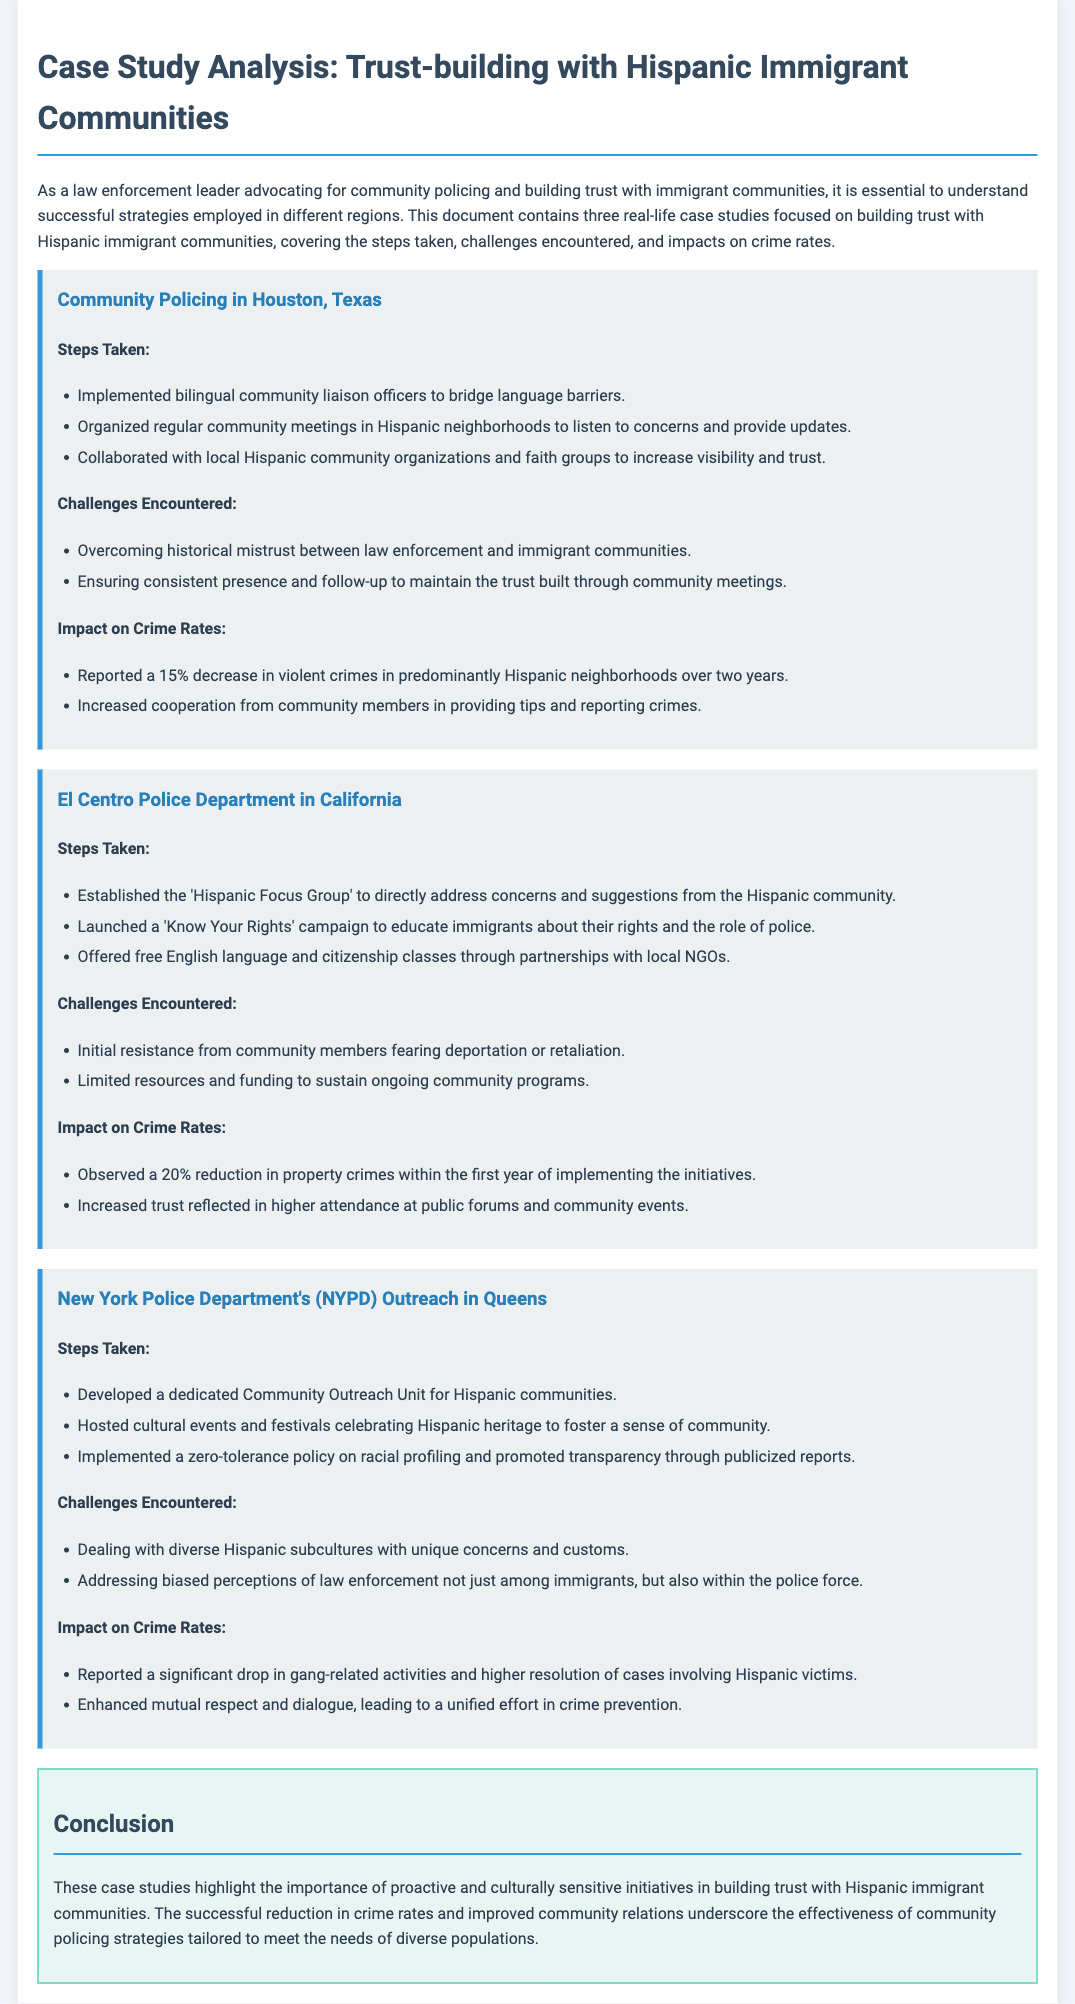What are the main steps taken in the Houston case study? The main steps include implementing bilingual community liaison officers, organizing regular community meetings, and collaborating with local organizations.
Answer: Bilingual community liaison officers, regular community meetings, collaborating with local organizations What was the percentage decrease in violent crimes in Houston? The document states that there was a 15% decrease in violent crimes in predominantly Hispanic neighborhoods.
Answer: 15% What challenges did the El Centro Police Department encounter? The challenges included initial resistance from community members fearing deportation and limited resources to sustain programs.
Answer: Initial resistance, limited resources What successful initiative was taken by NYPD in Queens? NYPD developed a dedicated Community Outreach Unit for Hispanic communities.
Answer: Dedicated Community Outreach Unit What community program did El Centro launch? El Centro launched a 'Know Your Rights' campaign to educate immigrants.
Answer: 'Know Your Rights' campaign What significant outcome did the NYPD report? NYPD reported a significant drop in gang-related activities and higher resolution of cases.
Answer: Drop in gang-related activities What was the impact of the trust-building efforts in El Centro on crime rates? The impact was a 20% reduction in property crimes within the first year.
Answer: 20% reduction Which city implemented a zero-tolerance policy on racial profiling? The NYPD in Queens implemented a zero-tolerance policy on racial profiling.
Answer: NYPD What was the purpose of hosting cultural events by NYPD? The purpose was to foster a sense of community.
Answer: Foster a sense of community 